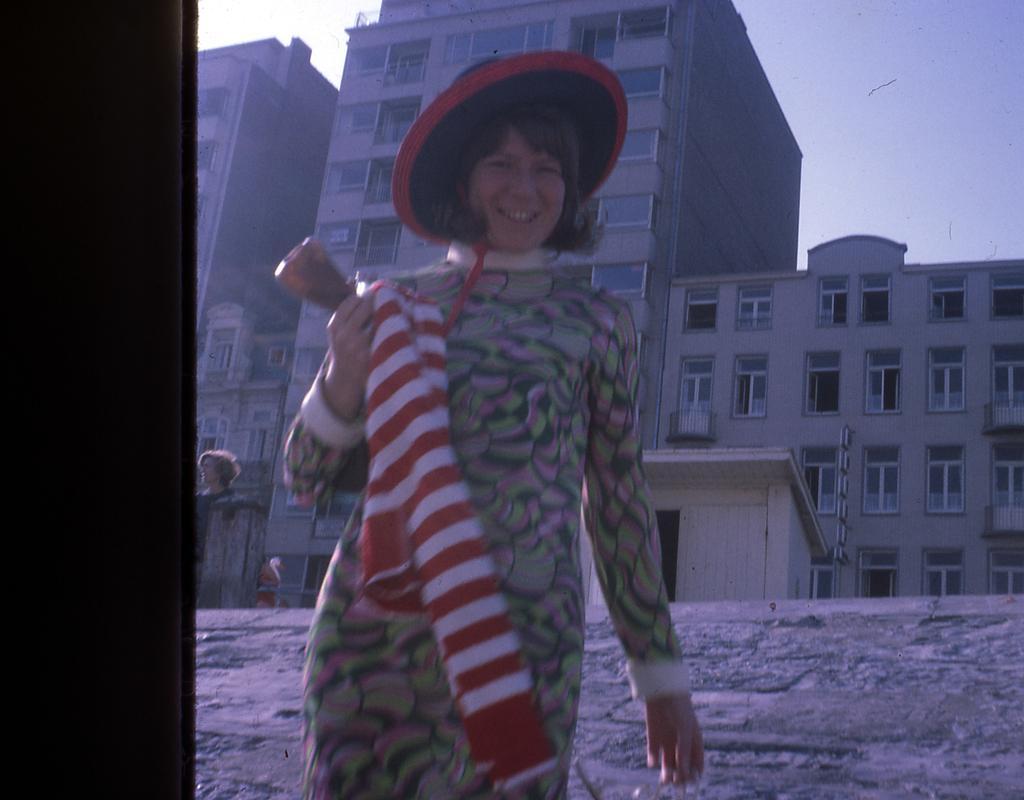Could you give a brief overview of what you see in this image? In this picture there is a woman standing and smiling and holding a cloth and an object, behind her we can see a person, buildings and sky. On the left side of the image it is dark. 